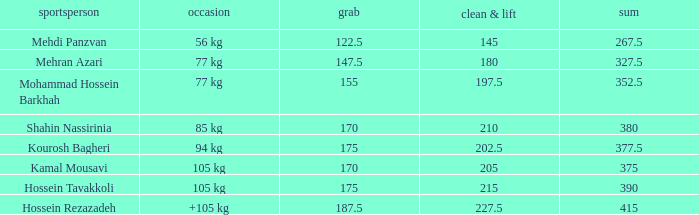How many snatches were there with a total of 267.5? 0.0. 